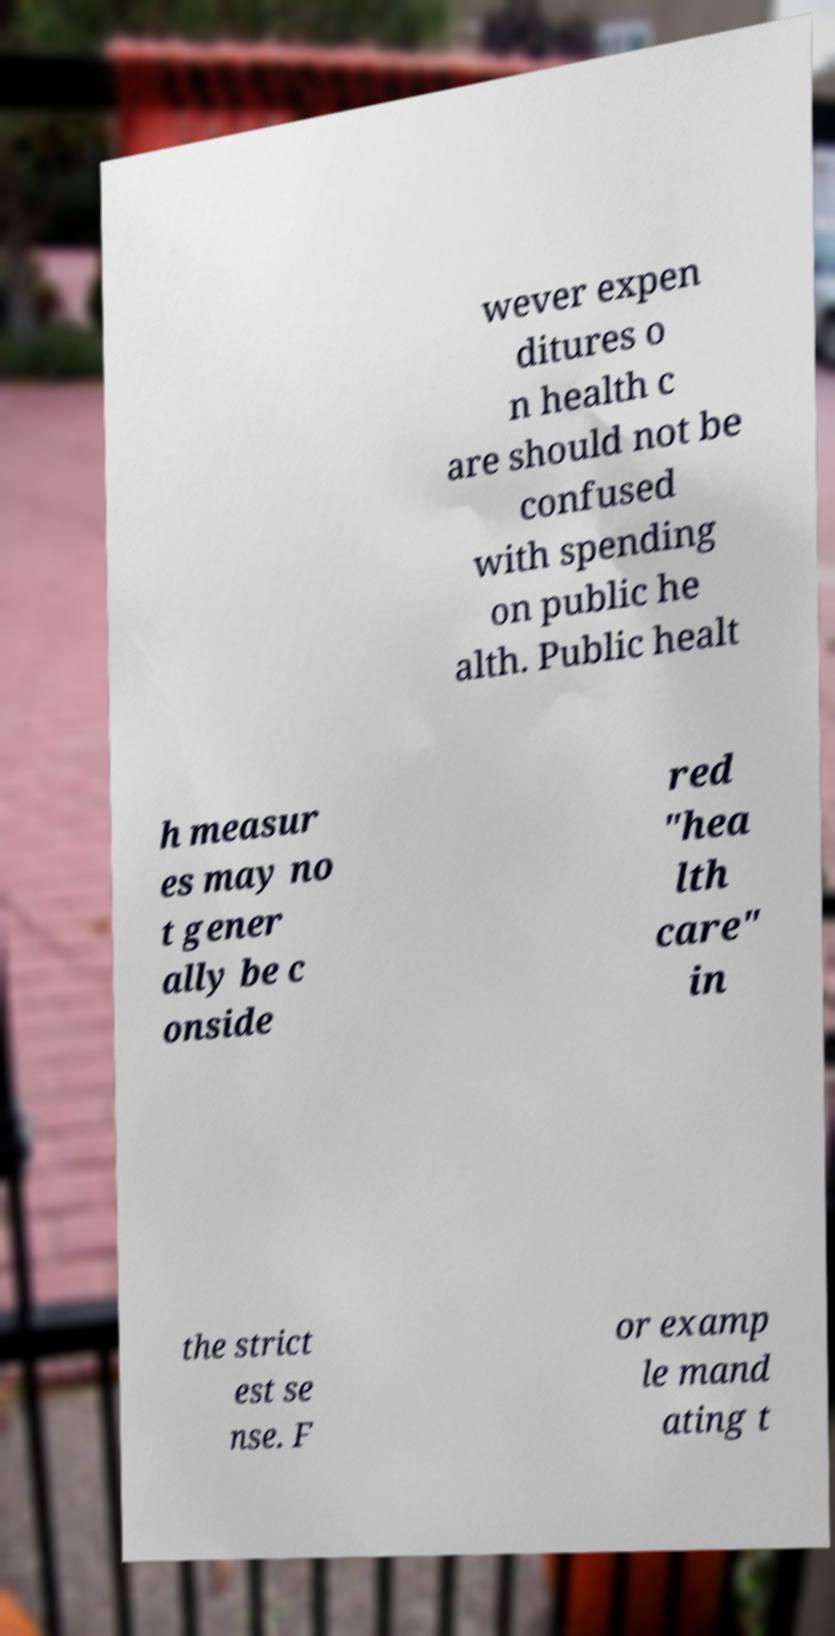Could you assist in decoding the text presented in this image and type it out clearly? wever expen ditures o n health c are should not be confused with spending on public he alth. Public healt h measur es may no t gener ally be c onside red "hea lth care" in the strict est se nse. F or examp le mand ating t 